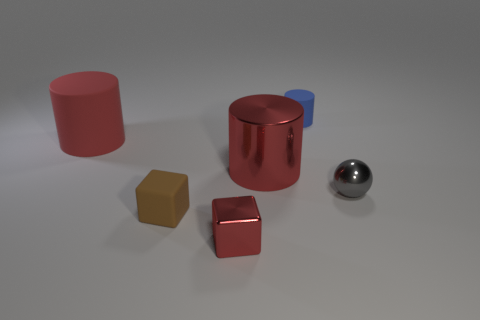The rubber object that is the same color as the metallic block is what shape?
Your answer should be compact. Cylinder. Is the number of objects that are in front of the shiny sphere greater than the number of metal balls?
Ensure brevity in your answer.  Yes. There is a red cube that is made of the same material as the small gray ball; what size is it?
Offer a terse response. Small. Are there any red metal blocks on the right side of the tiny rubber block?
Give a very brief answer. Yes. Does the small brown thing have the same shape as the tiny red metal thing?
Give a very brief answer. Yes. There is a metal sphere to the right of the red object on the right side of the metal thing that is in front of the ball; what is its size?
Keep it short and to the point. Small. What material is the blue object?
Ensure brevity in your answer.  Rubber. The shiny cylinder that is the same color as the small shiny block is what size?
Make the answer very short. Large. There is a brown rubber thing; does it have the same shape as the small metallic thing that is to the left of the tiny cylinder?
Provide a succinct answer. Yes. What is the material of the big object on the left side of the matte thing in front of the object that is right of the tiny blue matte cylinder?
Ensure brevity in your answer.  Rubber. 